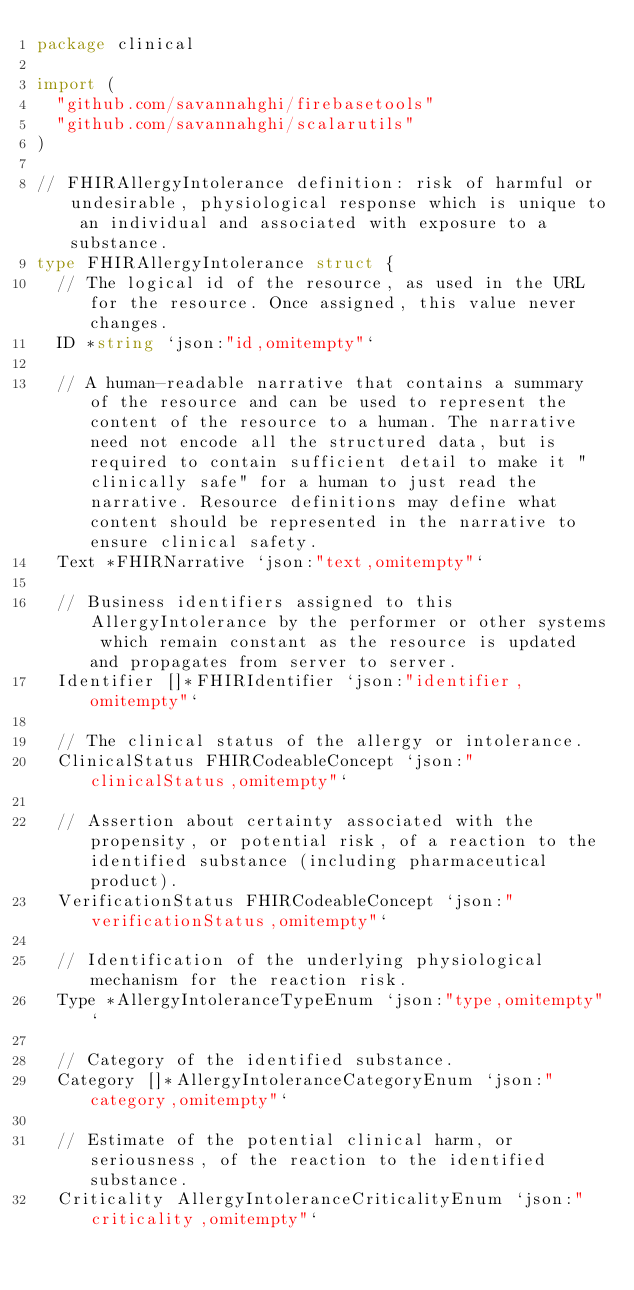Convert code to text. <code><loc_0><loc_0><loc_500><loc_500><_Go_>package clinical

import (
	"github.com/savannahghi/firebasetools"
	"github.com/savannahghi/scalarutils"
)

// FHIRAllergyIntolerance definition: risk of harmful or undesirable, physiological response which is unique to an individual and associated with exposure to a substance.
type FHIRAllergyIntolerance struct {
	// The logical id of the resource, as used in the URL for the resource. Once assigned, this value never changes.
	ID *string `json:"id,omitempty"`

	// A human-readable narrative that contains a summary of the resource and can be used to represent the content of the resource to a human. The narrative need not encode all the structured data, but is required to contain sufficient detail to make it "clinically safe" for a human to just read the narrative. Resource definitions may define what content should be represented in the narrative to ensure clinical safety.
	Text *FHIRNarrative `json:"text,omitempty"`

	// Business identifiers assigned to this AllergyIntolerance by the performer or other systems which remain constant as the resource is updated and propagates from server to server.
	Identifier []*FHIRIdentifier `json:"identifier,omitempty"`

	// The clinical status of the allergy or intolerance.
	ClinicalStatus FHIRCodeableConcept `json:"clinicalStatus,omitempty"`

	// Assertion about certainty associated with the propensity, or potential risk, of a reaction to the identified substance (including pharmaceutical product).
	VerificationStatus FHIRCodeableConcept `json:"verificationStatus,omitempty"`

	// Identification of the underlying physiological mechanism for the reaction risk.
	Type *AllergyIntoleranceTypeEnum `json:"type,omitempty"`

	// Category of the identified substance.
	Category []*AllergyIntoleranceCategoryEnum `json:"category,omitempty"`

	// Estimate of the potential clinical harm, or seriousness, of the reaction to the identified substance.
	Criticality AllergyIntoleranceCriticalityEnum `json:"criticality,omitempty"`
</code> 